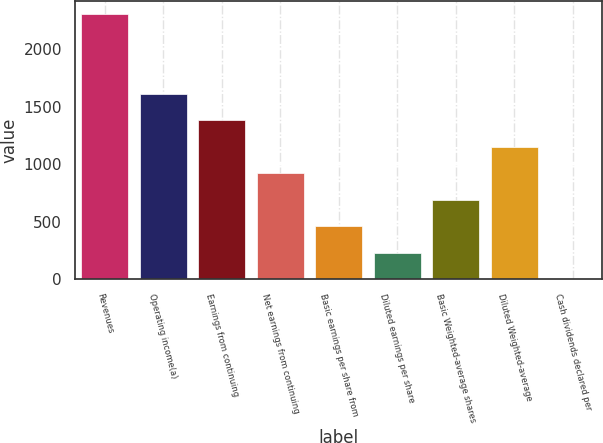Convert chart. <chart><loc_0><loc_0><loc_500><loc_500><bar_chart><fcel>Revenues<fcel>Operating income(a)<fcel>Earnings from continuing<fcel>Net earnings from continuing<fcel>Basic earnings per share from<fcel>Diluted earnings per share<fcel>Basic Weighted-average shares<fcel>Diluted Weighted-average<fcel>Cash dividends declared per<nl><fcel>2303.5<fcel>1612.67<fcel>1382.38<fcel>921.8<fcel>461.22<fcel>230.93<fcel>691.51<fcel>1152.09<fcel>0.64<nl></chart> 